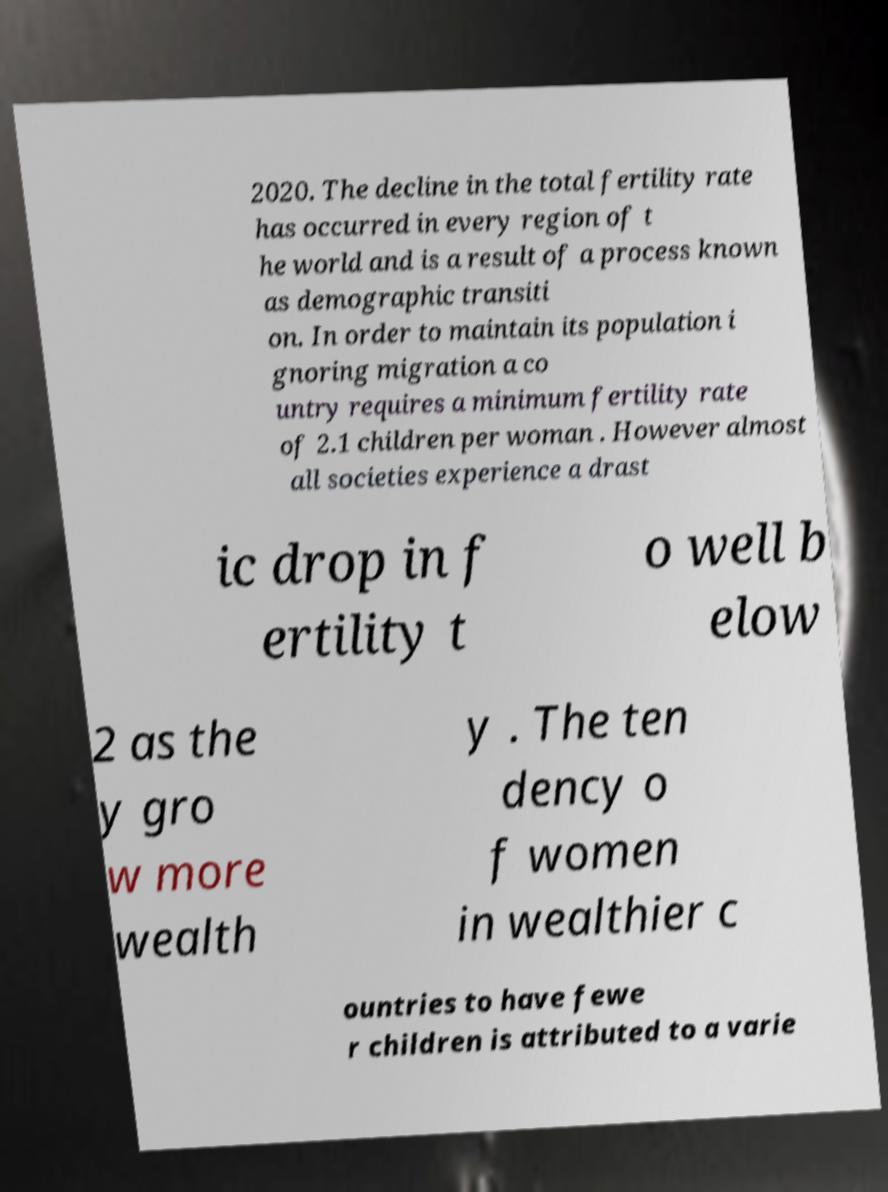For documentation purposes, I need the text within this image transcribed. Could you provide that? 2020. The decline in the total fertility rate has occurred in every region of t he world and is a result of a process known as demographic transiti on. In order to maintain its population i gnoring migration a co untry requires a minimum fertility rate of 2.1 children per woman . However almost all societies experience a drast ic drop in f ertility t o well b elow 2 as the y gro w more wealth y . The ten dency o f women in wealthier c ountries to have fewe r children is attributed to a varie 